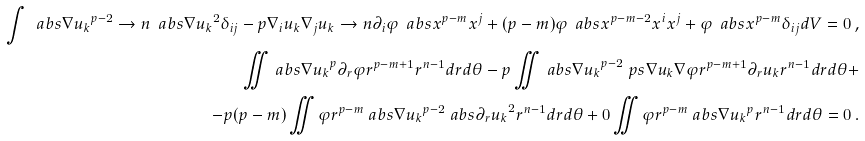<formula> <loc_0><loc_0><loc_500><loc_500>\int \ a b s { \nabla u _ { k } } ^ { p - 2 } \to n { \ a b s { \nabla u _ { k } } ^ { 2 } \delta _ { i j } - p \nabla _ { i } u _ { k } \nabla _ { j } u _ { k } } \to n { \partial _ { i } \varphi \ a b s x ^ { p - m } x ^ { j } + ( p - m ) \varphi \ a b s x ^ { p - m - 2 } x ^ { i } x ^ { j } + \varphi \ a b s x ^ { p - m } \delta _ { i j } } d V = 0 \, , \\ \iint \ a b s { \nabla u _ { k } } ^ { p } \partial _ { r } \varphi r ^ { p - m + 1 } r ^ { n - 1 } d r d \theta - p \iint \ a b s { \nabla u _ { k } } ^ { p - 2 } \ p s { \nabla u _ { k } } { \nabla \varphi } r ^ { p - m + 1 } \partial _ { r } u _ { k } r ^ { n - 1 } d r d \theta + \\ - p ( p - m ) \iint \varphi r ^ { p - m } \ a b s { \nabla u _ { k } } ^ { p - 2 } \ a b s { \partial _ { r } u _ { k } } ^ { 2 } r ^ { n - 1 } d r d \theta + 0 \iint \varphi r ^ { p - m } \ a b s { \nabla u _ { k } } ^ { p } r ^ { n - 1 } d r d \theta = 0 \, .</formula> 